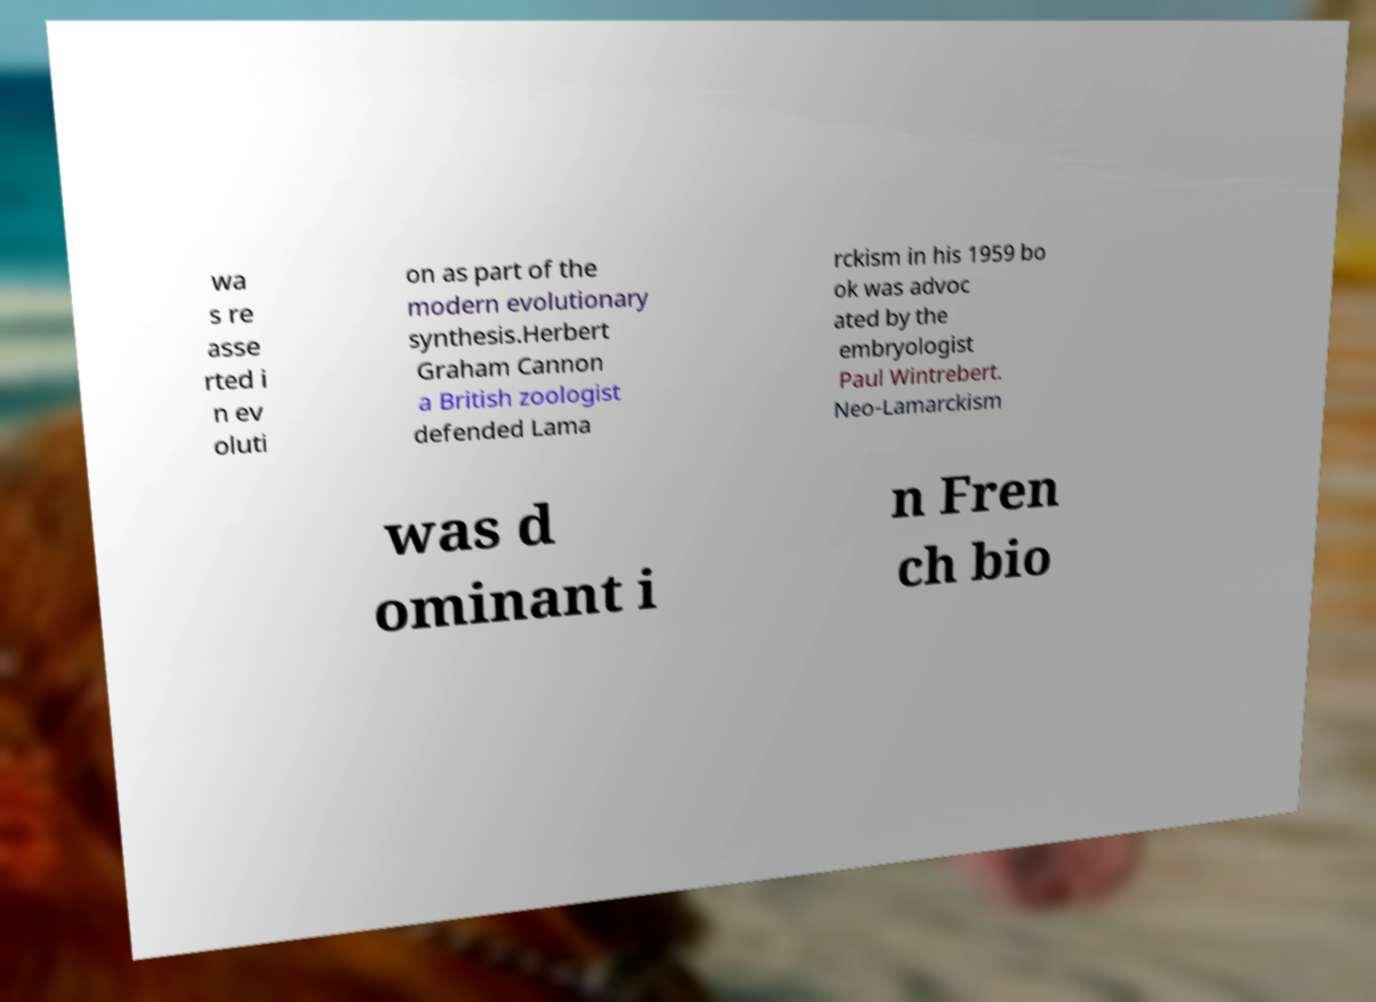Please identify and transcribe the text found in this image. wa s re asse rted i n ev oluti on as part of the modern evolutionary synthesis.Herbert Graham Cannon a British zoologist defended Lama rckism in his 1959 bo ok was advoc ated by the embryologist Paul Wintrebert. Neo-Lamarckism was d ominant i n Fren ch bio 